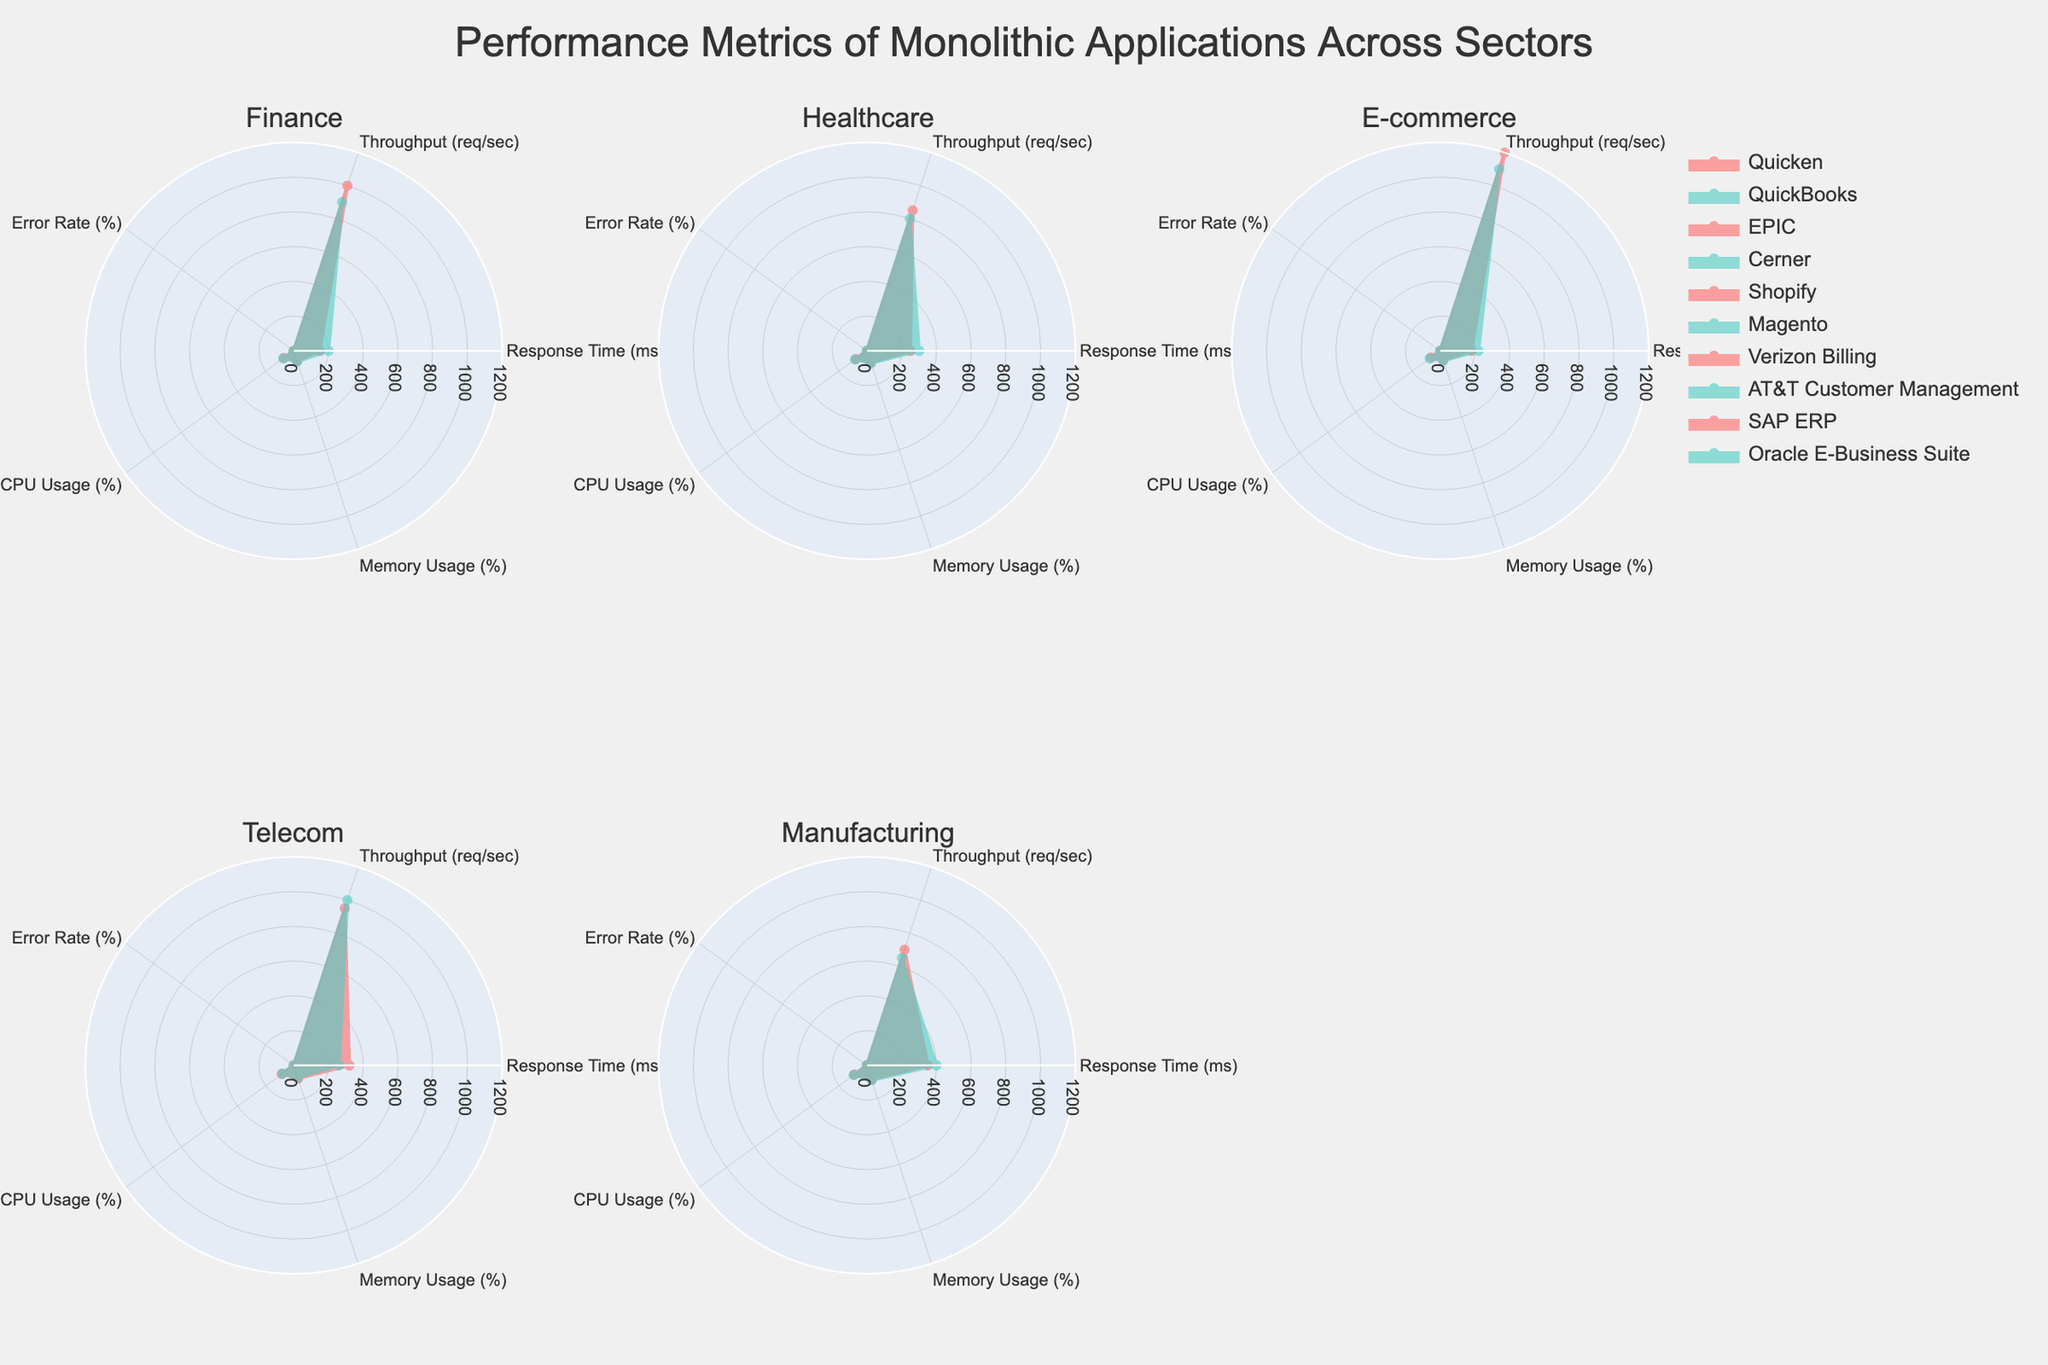How many sectors are compared in the figure? The title mentions different monolithic applications across sectors, and the subplots count is indicative. Counting the subplot titles, there are six sectors presented.
Answer: Six Which Finance application has a shorter response time, Quicken or QuickBooks? Comparing the response time metrics on the radar chart for the Finance sector subplots, Quicken has a shorter response time (150 ms) compared to QuickBooks (200 ms).
Answer: Quicken What is the sector with the highest CPU usage on average? Compute the average CPU usage for each sector by summing the CPU usages of applications and dividing by the number of applications within that sector. The sector with the highest average CPU usage is identified by comparing these averages.
Answer: Manufacturing Which sector's applications have the lowest error rates overall? Observe the error rate values in each sector's radar charts. E-commerce applications (Shopify and Magento) consistently have the lowest error rates (0.4% and 0.5%).
Answer: E-commerce In the Telecom sector, which application uses less CPU, Verizon Billing or AT&T Customer Management? Refer to the CPU usage metrics for these applications in the Telecom sector. Verizon Billing shows 85% CPU usage, while AT&T Customer Management has 80%. Hence, AT&T Customer Management uses less CPU.
Answer: AT&T Customer Management What is the difference in memory usage between SAP ERP and Oracle E-Business Suite in the Manufacturing sector? Subtract the memory usage of SAP ERP (85%) from that of Oracle E-Business Suite (90%) to find the difference.
Answer: 5% Which application in the Healthcare sector has a higher throughput, EPIC or Cerner? Look at the throughput values for EPIC and Cerner in the Healthcare radar subplot. EPIC has a higher throughput (850 req/sec) compared to Cerner (800 req/sec).
Answer: EPIC What is the average error rate for the applications in the Healthcare sector? Add the error rates of EPIC (1.1%) and Cerner (1.3%), and then divide by the number of applications (2) to find the average error rate for Healthcare applications.
Answer: 1.2% Compare the response times of Shopify and Magento in the E-commerce sector. Which one is faster? Observe the response time metrics: Shopify has a response time of 180 ms, while Magento has a response time of 220 ms. Shopify is faster.
Answer: Shopify In which sector do we see the most consistency across applications for memory usage? Check the memory usage values for both applications in each sector. The Telecom sector shows the most consistency with Verizon Billing at 80% and AT&T Customer Management at 75%.
Answer: Telecom 